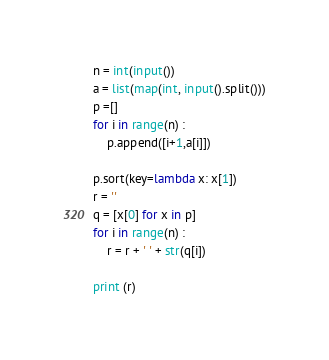<code> <loc_0><loc_0><loc_500><loc_500><_Python_>n = int(input())
a = list(map(int, input().split()))
p =[]
for i in range(n) :
    p.append([i+1,a[i]])

p.sort(key=lambda x: x[1])
r = ''
q = [x[0] for x in p]
for i in range(n) :
    r = r + ' ' + str(q[i])

print (r)</code> 